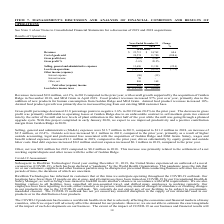From Ricebran Technologies's financial document, What are the respective revenues from operations in 2018 and 2019? The document shows two values: $14,762 and $23,713 (in thousands). From the document: "Revenues 23,713 $ 14,762 $ 60.6 Revenues 23,713 $ 14,762 $ 60.6..." Also, What are the respective cost of goods sold from operations in 2018 and 2019? The document shows two values: 11,780 and 24,574 (in thousands). From the document: "Cost of goods sold 24,574 11,780 (108.6) Cost of goods sold 24,574 11,780 (108.6)..." Also, What are the respective selling, general and administrative expenses from operations in 2018 and 2019? The document shows two values: 11,194 and 13,696 (in thousands). From the document: "lling, general and administrative expenses 13,696 11,194 (22.4) Selling, general and administrative expenses 13,696 11,194 (22.4)..." Also, can you calculate: What is the average revenues from operations in 2018 and 2019? To answer this question, I need to perform calculations using the financial data. The calculation is: ($14,762 + $23,713)/2 , which equals 19237.5 (in thousands). This is based on the information: "Revenues 23,713 $ 14,762 $ 60.6 Revenues 23,713 $ 14,762 $ 60.6..." The key data points involved are: 14,762, 23,713. Also, can you calculate: What is the percentage change in the cost of goods sold from operations in 2018 and 2019? To answer this question, I need to perform calculations using the financial data. The calculation is: (24,574 - 11,780)/11,780 , which equals 108.61 (percentage). This is based on the information: "Cost of goods sold 24,574 11,780 (108.6) Cost of goods sold 24,574 11,780 (108.6)..." The key data points involved are: 11,780, 24,574. Also, can you calculate: What is the percentage change in selling, general and administrative expenses from operations in 2018 and 2019? To answer this question, I need to perform calculations using the financial data. The calculation is: (13,696 - 11,194)/11,194 , which equals 22.35 (percentage). This is based on the information: "lling, general and administrative expenses 13,696 11,194 (22.4) Selling, general and administrative expenses 13,696 11,194 (22.4)..." The key data points involved are: 11,194, 13,696. 